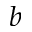<formula> <loc_0><loc_0><loc_500><loc_500>b</formula> 